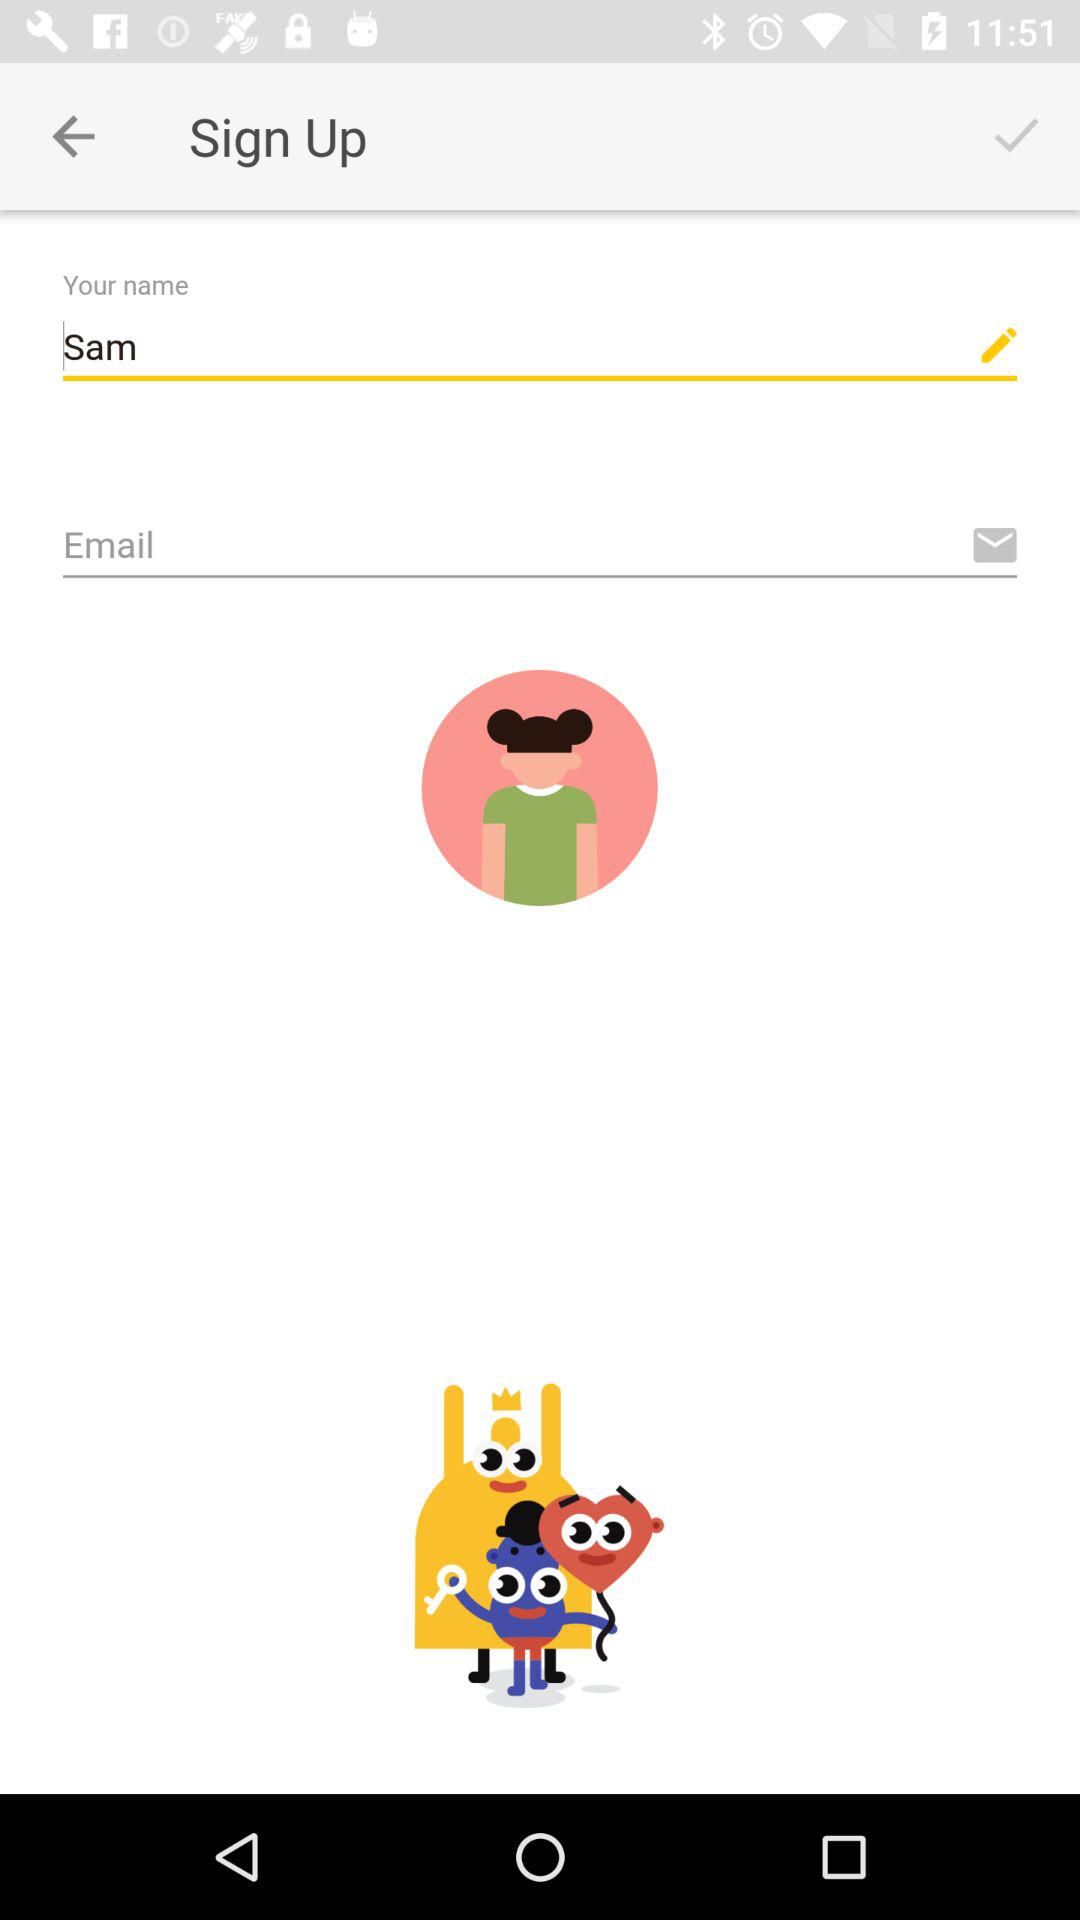What is the email address?
When the provided information is insufficient, respond with <no answer>. <no answer> 